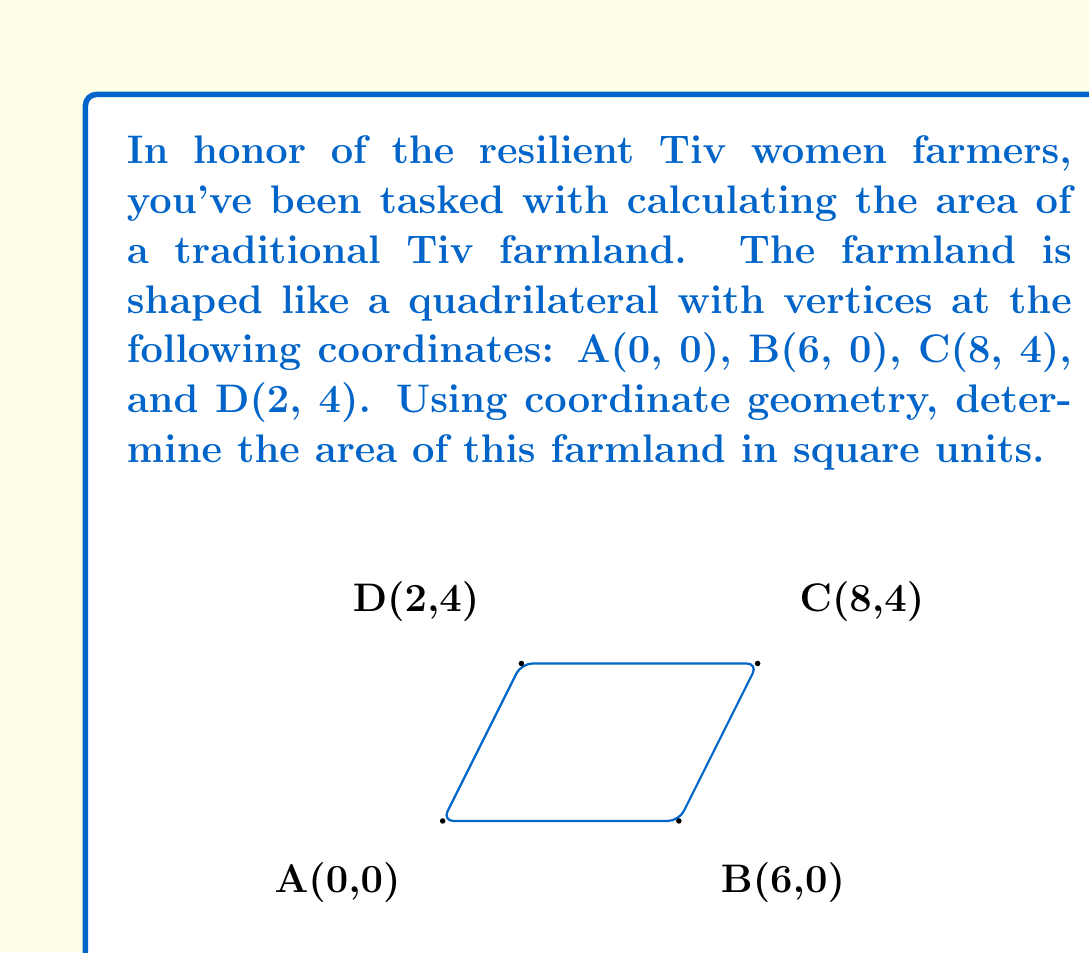Solve this math problem. To calculate the area of this quadrilateral farmland, we can use the shoelace formula (also known as the surveyor's formula). This method is particularly useful when we have the coordinates of the vertices.

The shoelace formula for a quadrilateral ABCD with coordinates $(x_1, y_1)$, $(x_2, y_2)$, $(x_3, y_3)$, and $(x_4, y_4)$ is:

$$\text{Area} = \frac{1}{2}|(x_1y_2 + x_2y_3 + x_3y_4 + x_4y_1) - (y_1x_2 + y_2x_3 + y_3x_4 + y_4x_1)|$$

Let's substitute the given coordinates:
A(0, 0), B(6, 0), C(8, 4), D(2, 4)

$$\begin{align*}
\text{Area} &= \frac{1}{2}|(0 \cdot 0 + 6 \cdot 4 + 8 \cdot 4 + 2 \cdot 0) - (0 \cdot 6 + 0 \cdot 8 + 4 \cdot 2 + 4 \cdot 0)| \\[10pt]
&= \frac{1}{2}|(0 + 24 + 32 + 0) - (0 + 0 + 8 + 0)| \\[10pt]
&= \frac{1}{2}|56 - 8| \\[10pt]
&= \frac{1}{2} \cdot 48 \\[10pt]
&= 24
\end{align*}$$

Therefore, the area of the Tiv farmland is 24 square units.
Answer: 24 square units 